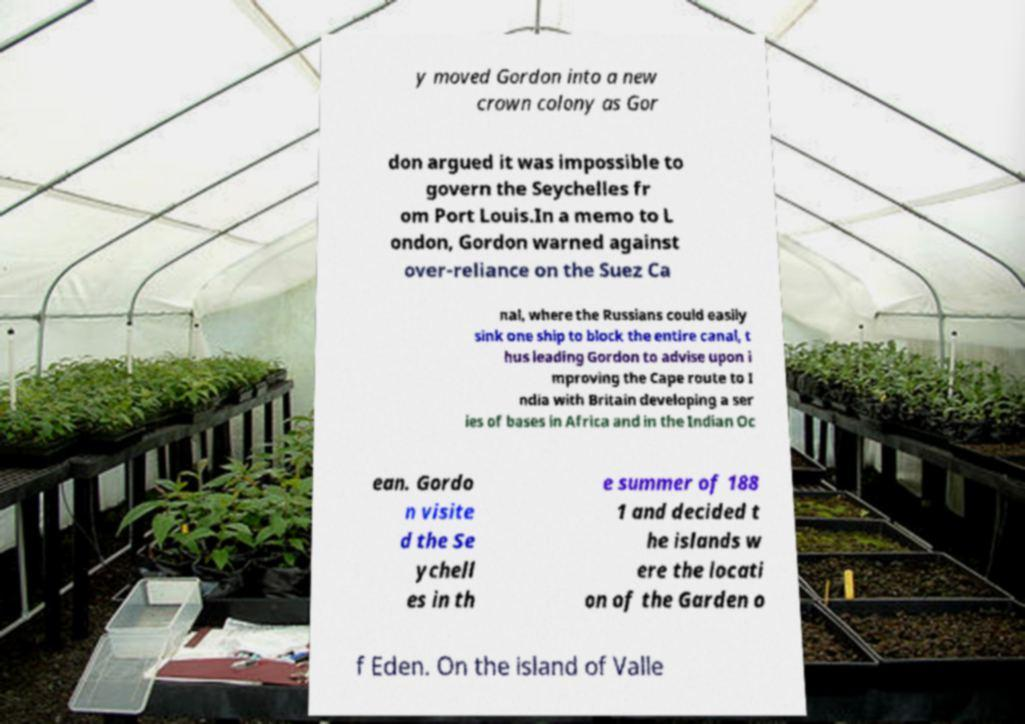There's text embedded in this image that I need extracted. Can you transcribe it verbatim? y moved Gordon into a new crown colony as Gor don argued it was impossible to govern the Seychelles fr om Port Louis.In a memo to L ondon, Gordon warned against over-reliance on the Suez Ca nal, where the Russians could easily sink one ship to block the entire canal, t hus leading Gordon to advise upon i mproving the Cape route to I ndia with Britain developing a ser ies of bases in Africa and in the Indian Oc ean. Gordo n visite d the Se ychell es in th e summer of 188 1 and decided t he islands w ere the locati on of the Garden o f Eden. On the island of Valle 